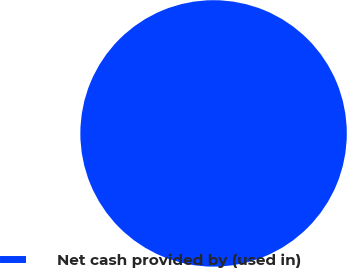Convert chart to OTSL. <chart><loc_0><loc_0><loc_500><loc_500><pie_chart><fcel>Net cash provided by (used in)<nl><fcel>100.0%<nl></chart> 